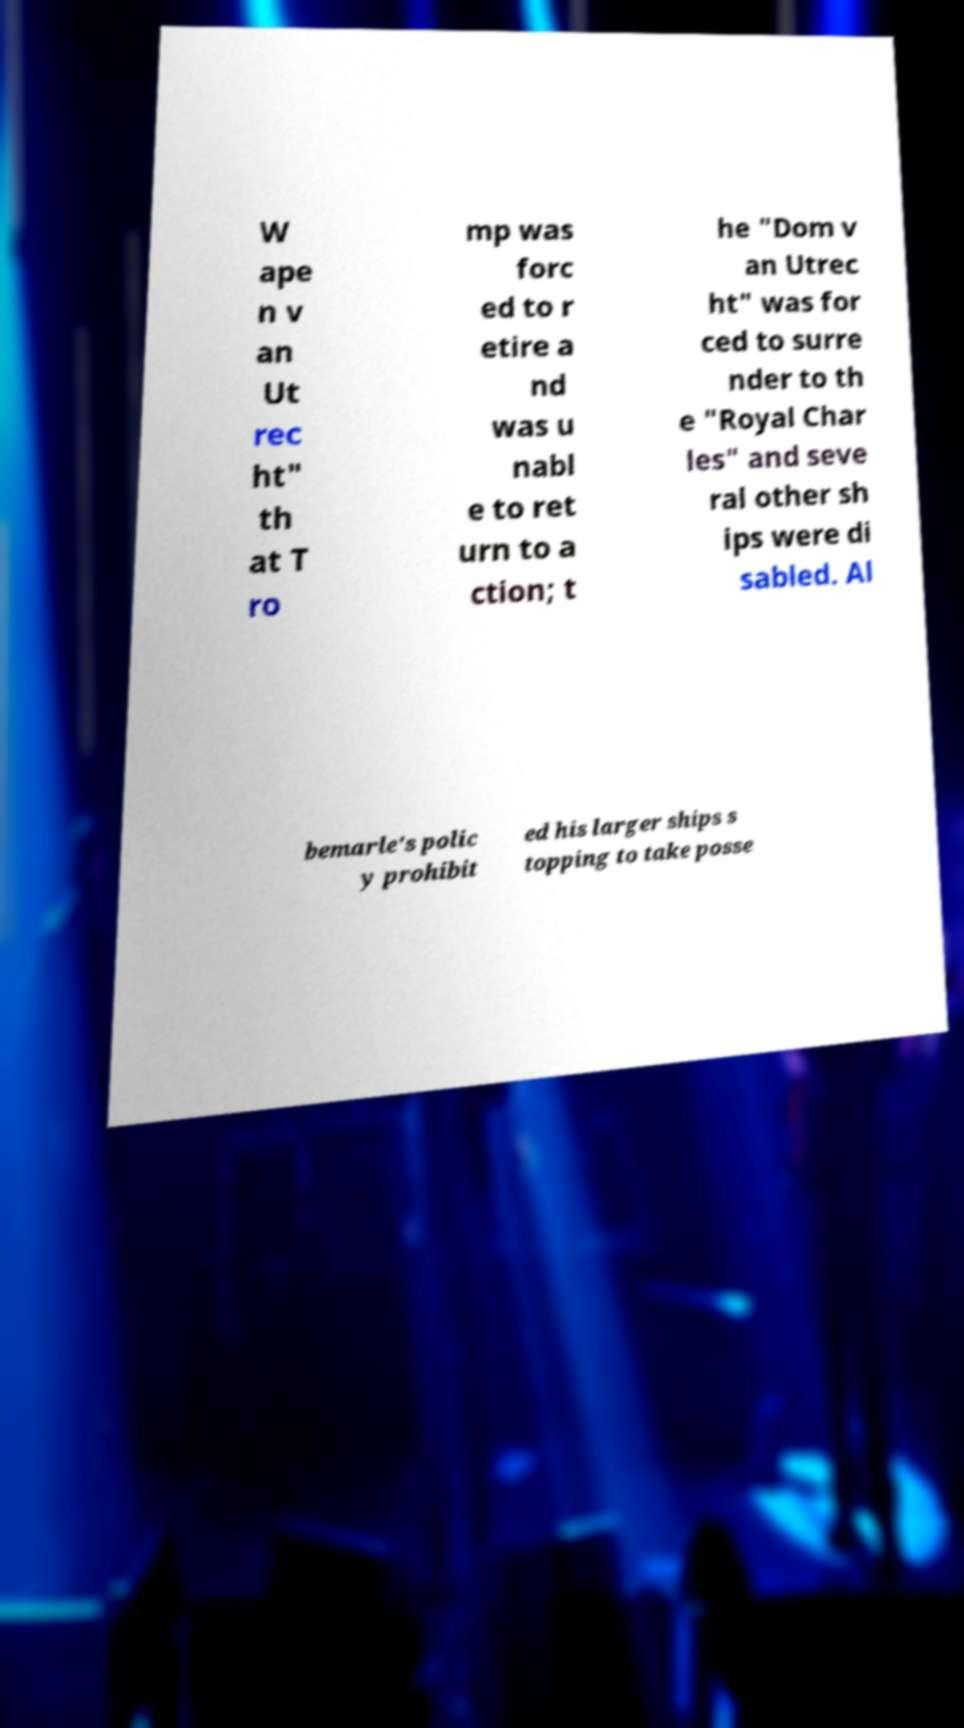Please read and relay the text visible in this image. What does it say? W ape n v an Ut rec ht" th at T ro mp was forc ed to r etire a nd was u nabl e to ret urn to a ction; t he "Dom v an Utrec ht" was for ced to surre nder to th e "Royal Char les" and seve ral other sh ips were di sabled. Al bemarle's polic y prohibit ed his larger ships s topping to take posse 